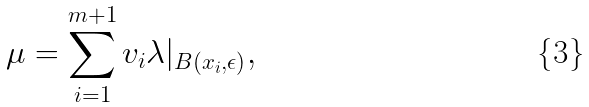<formula> <loc_0><loc_0><loc_500><loc_500>\mu = \sum _ { i = 1 } ^ { m + 1 } v _ { i } \lambda | _ { B ( x _ { i } , \epsilon ) } ,</formula> 